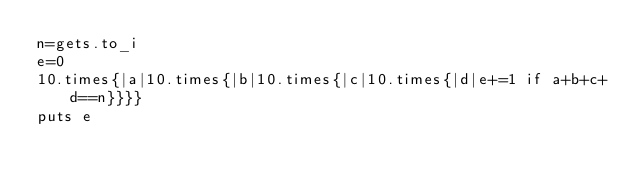<code> <loc_0><loc_0><loc_500><loc_500><_Ruby_>n=gets.to_i
e=0
10.times{|a|10.times{|b|10.times{|c|10.times{|d|e+=1 if a+b+c+d==n}}}}
puts e</code> 